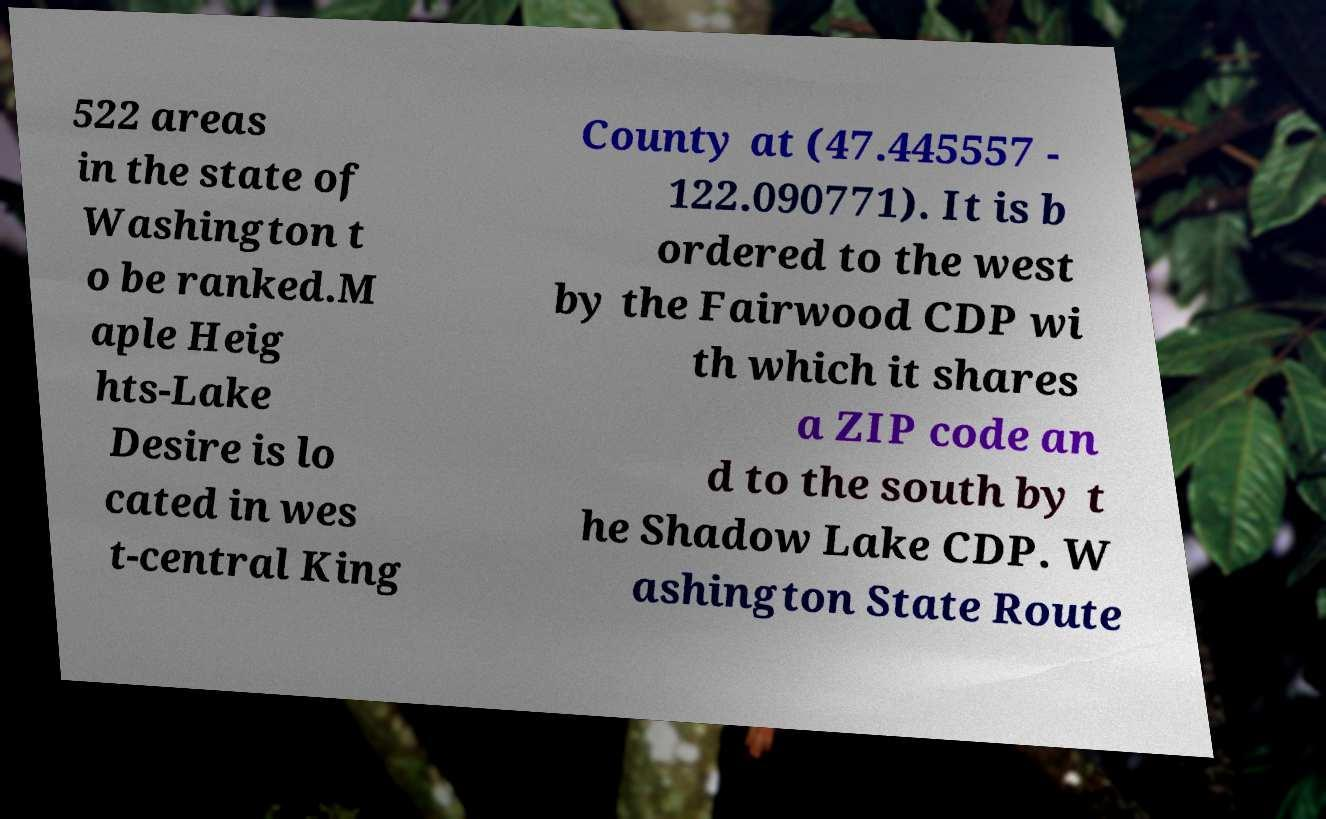Please read and relay the text visible in this image. What does it say? 522 areas in the state of Washington t o be ranked.M aple Heig hts-Lake Desire is lo cated in wes t-central King County at (47.445557 - 122.090771). It is b ordered to the west by the Fairwood CDP wi th which it shares a ZIP code an d to the south by t he Shadow Lake CDP. W ashington State Route 